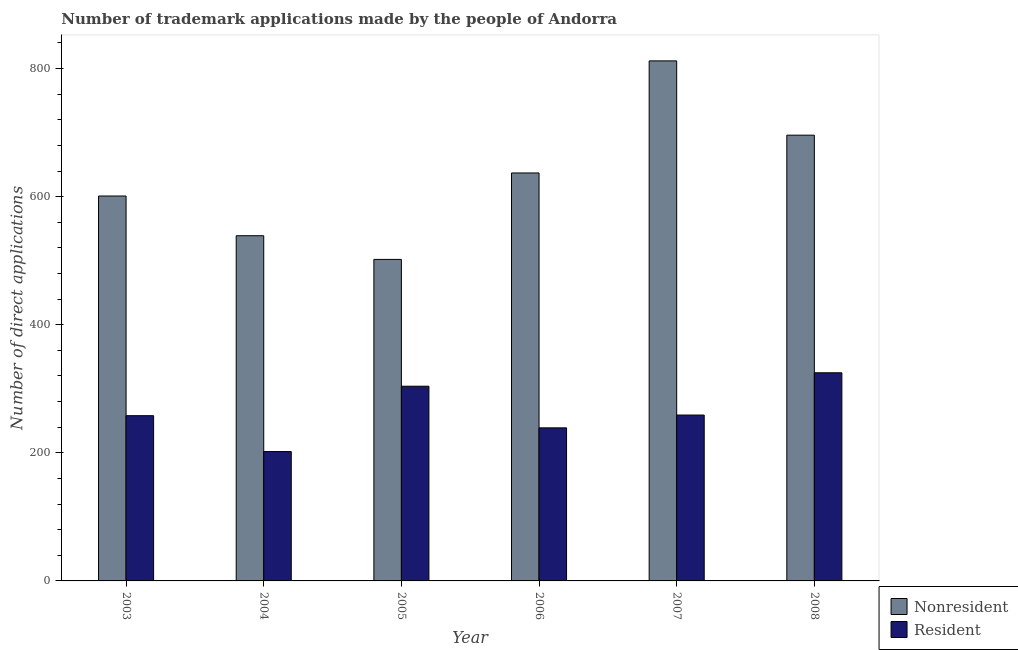How many different coloured bars are there?
Give a very brief answer. 2. Are the number of bars on each tick of the X-axis equal?
Provide a short and direct response. Yes. How many bars are there on the 6th tick from the left?
Keep it short and to the point. 2. How many bars are there on the 6th tick from the right?
Ensure brevity in your answer.  2. What is the number of trademark applications made by residents in 2004?
Provide a succinct answer. 202. Across all years, what is the maximum number of trademark applications made by residents?
Ensure brevity in your answer.  325. Across all years, what is the minimum number of trademark applications made by non residents?
Your response must be concise. 502. In which year was the number of trademark applications made by non residents minimum?
Ensure brevity in your answer.  2005. What is the total number of trademark applications made by non residents in the graph?
Ensure brevity in your answer.  3787. What is the difference between the number of trademark applications made by non residents in 2004 and that in 2007?
Give a very brief answer. -273. What is the difference between the number of trademark applications made by residents in 2005 and the number of trademark applications made by non residents in 2006?
Ensure brevity in your answer.  65. What is the average number of trademark applications made by non residents per year?
Ensure brevity in your answer.  631.17. In the year 2006, what is the difference between the number of trademark applications made by residents and number of trademark applications made by non residents?
Ensure brevity in your answer.  0. In how many years, is the number of trademark applications made by residents greater than 560?
Keep it short and to the point. 0. What is the ratio of the number of trademark applications made by non residents in 2005 to that in 2008?
Keep it short and to the point. 0.72. Is the number of trademark applications made by residents in 2003 less than that in 2006?
Offer a terse response. No. Is the difference between the number of trademark applications made by residents in 2005 and 2006 greater than the difference between the number of trademark applications made by non residents in 2005 and 2006?
Provide a succinct answer. No. What is the difference between the highest and the second highest number of trademark applications made by non residents?
Offer a terse response. 116. What is the difference between the highest and the lowest number of trademark applications made by residents?
Make the answer very short. 123. What does the 2nd bar from the left in 2003 represents?
Your answer should be very brief. Resident. What does the 1st bar from the right in 2004 represents?
Your answer should be very brief. Resident. How many bars are there?
Provide a short and direct response. 12. Are all the bars in the graph horizontal?
Your answer should be very brief. No. How many years are there in the graph?
Your answer should be very brief. 6. Does the graph contain any zero values?
Give a very brief answer. No. Where does the legend appear in the graph?
Give a very brief answer. Bottom right. How many legend labels are there?
Ensure brevity in your answer.  2. How are the legend labels stacked?
Ensure brevity in your answer.  Vertical. What is the title of the graph?
Your answer should be very brief. Number of trademark applications made by the people of Andorra. What is the label or title of the Y-axis?
Your answer should be compact. Number of direct applications. What is the Number of direct applications in Nonresident in 2003?
Provide a succinct answer. 601. What is the Number of direct applications in Resident in 2003?
Provide a short and direct response. 258. What is the Number of direct applications in Nonresident in 2004?
Ensure brevity in your answer.  539. What is the Number of direct applications in Resident in 2004?
Your answer should be compact. 202. What is the Number of direct applications in Nonresident in 2005?
Offer a very short reply. 502. What is the Number of direct applications of Resident in 2005?
Your response must be concise. 304. What is the Number of direct applications of Nonresident in 2006?
Offer a very short reply. 637. What is the Number of direct applications of Resident in 2006?
Your answer should be very brief. 239. What is the Number of direct applications in Nonresident in 2007?
Provide a succinct answer. 812. What is the Number of direct applications of Resident in 2007?
Your answer should be compact. 259. What is the Number of direct applications in Nonresident in 2008?
Offer a terse response. 696. What is the Number of direct applications in Resident in 2008?
Give a very brief answer. 325. Across all years, what is the maximum Number of direct applications in Nonresident?
Your answer should be compact. 812. Across all years, what is the maximum Number of direct applications of Resident?
Offer a very short reply. 325. Across all years, what is the minimum Number of direct applications of Nonresident?
Keep it short and to the point. 502. Across all years, what is the minimum Number of direct applications of Resident?
Give a very brief answer. 202. What is the total Number of direct applications of Nonresident in the graph?
Provide a short and direct response. 3787. What is the total Number of direct applications of Resident in the graph?
Ensure brevity in your answer.  1587. What is the difference between the Number of direct applications in Nonresident in 2003 and that in 2004?
Keep it short and to the point. 62. What is the difference between the Number of direct applications of Resident in 2003 and that in 2005?
Your answer should be compact. -46. What is the difference between the Number of direct applications of Nonresident in 2003 and that in 2006?
Provide a short and direct response. -36. What is the difference between the Number of direct applications of Resident in 2003 and that in 2006?
Your answer should be very brief. 19. What is the difference between the Number of direct applications in Nonresident in 2003 and that in 2007?
Offer a very short reply. -211. What is the difference between the Number of direct applications of Nonresident in 2003 and that in 2008?
Your response must be concise. -95. What is the difference between the Number of direct applications of Resident in 2003 and that in 2008?
Your response must be concise. -67. What is the difference between the Number of direct applications of Resident in 2004 and that in 2005?
Your answer should be compact. -102. What is the difference between the Number of direct applications of Nonresident in 2004 and that in 2006?
Your answer should be compact. -98. What is the difference between the Number of direct applications in Resident in 2004 and that in 2006?
Give a very brief answer. -37. What is the difference between the Number of direct applications in Nonresident in 2004 and that in 2007?
Offer a terse response. -273. What is the difference between the Number of direct applications in Resident in 2004 and that in 2007?
Your answer should be compact. -57. What is the difference between the Number of direct applications in Nonresident in 2004 and that in 2008?
Give a very brief answer. -157. What is the difference between the Number of direct applications of Resident in 2004 and that in 2008?
Your answer should be compact. -123. What is the difference between the Number of direct applications in Nonresident in 2005 and that in 2006?
Your answer should be very brief. -135. What is the difference between the Number of direct applications of Resident in 2005 and that in 2006?
Your response must be concise. 65. What is the difference between the Number of direct applications in Nonresident in 2005 and that in 2007?
Ensure brevity in your answer.  -310. What is the difference between the Number of direct applications in Nonresident in 2005 and that in 2008?
Offer a terse response. -194. What is the difference between the Number of direct applications in Resident in 2005 and that in 2008?
Offer a very short reply. -21. What is the difference between the Number of direct applications of Nonresident in 2006 and that in 2007?
Your answer should be compact. -175. What is the difference between the Number of direct applications in Resident in 2006 and that in 2007?
Provide a succinct answer. -20. What is the difference between the Number of direct applications in Nonresident in 2006 and that in 2008?
Keep it short and to the point. -59. What is the difference between the Number of direct applications in Resident in 2006 and that in 2008?
Your answer should be compact. -86. What is the difference between the Number of direct applications of Nonresident in 2007 and that in 2008?
Keep it short and to the point. 116. What is the difference between the Number of direct applications in Resident in 2007 and that in 2008?
Your response must be concise. -66. What is the difference between the Number of direct applications of Nonresident in 2003 and the Number of direct applications of Resident in 2004?
Ensure brevity in your answer.  399. What is the difference between the Number of direct applications in Nonresident in 2003 and the Number of direct applications in Resident in 2005?
Offer a very short reply. 297. What is the difference between the Number of direct applications of Nonresident in 2003 and the Number of direct applications of Resident in 2006?
Ensure brevity in your answer.  362. What is the difference between the Number of direct applications in Nonresident in 2003 and the Number of direct applications in Resident in 2007?
Your answer should be compact. 342. What is the difference between the Number of direct applications in Nonresident in 2003 and the Number of direct applications in Resident in 2008?
Offer a terse response. 276. What is the difference between the Number of direct applications of Nonresident in 2004 and the Number of direct applications of Resident in 2005?
Your response must be concise. 235. What is the difference between the Number of direct applications of Nonresident in 2004 and the Number of direct applications of Resident in 2006?
Ensure brevity in your answer.  300. What is the difference between the Number of direct applications of Nonresident in 2004 and the Number of direct applications of Resident in 2007?
Give a very brief answer. 280. What is the difference between the Number of direct applications in Nonresident in 2004 and the Number of direct applications in Resident in 2008?
Offer a very short reply. 214. What is the difference between the Number of direct applications in Nonresident in 2005 and the Number of direct applications in Resident in 2006?
Offer a very short reply. 263. What is the difference between the Number of direct applications of Nonresident in 2005 and the Number of direct applications of Resident in 2007?
Ensure brevity in your answer.  243. What is the difference between the Number of direct applications in Nonresident in 2005 and the Number of direct applications in Resident in 2008?
Offer a terse response. 177. What is the difference between the Number of direct applications of Nonresident in 2006 and the Number of direct applications of Resident in 2007?
Offer a very short reply. 378. What is the difference between the Number of direct applications in Nonresident in 2006 and the Number of direct applications in Resident in 2008?
Your answer should be very brief. 312. What is the difference between the Number of direct applications of Nonresident in 2007 and the Number of direct applications of Resident in 2008?
Give a very brief answer. 487. What is the average Number of direct applications in Nonresident per year?
Your answer should be very brief. 631.17. What is the average Number of direct applications of Resident per year?
Offer a very short reply. 264.5. In the year 2003, what is the difference between the Number of direct applications in Nonresident and Number of direct applications in Resident?
Offer a terse response. 343. In the year 2004, what is the difference between the Number of direct applications of Nonresident and Number of direct applications of Resident?
Your answer should be compact. 337. In the year 2005, what is the difference between the Number of direct applications of Nonresident and Number of direct applications of Resident?
Keep it short and to the point. 198. In the year 2006, what is the difference between the Number of direct applications of Nonresident and Number of direct applications of Resident?
Give a very brief answer. 398. In the year 2007, what is the difference between the Number of direct applications in Nonresident and Number of direct applications in Resident?
Your response must be concise. 553. In the year 2008, what is the difference between the Number of direct applications in Nonresident and Number of direct applications in Resident?
Make the answer very short. 371. What is the ratio of the Number of direct applications in Nonresident in 2003 to that in 2004?
Give a very brief answer. 1.11. What is the ratio of the Number of direct applications of Resident in 2003 to that in 2004?
Make the answer very short. 1.28. What is the ratio of the Number of direct applications of Nonresident in 2003 to that in 2005?
Provide a succinct answer. 1.2. What is the ratio of the Number of direct applications in Resident in 2003 to that in 2005?
Offer a terse response. 0.85. What is the ratio of the Number of direct applications in Nonresident in 2003 to that in 2006?
Your answer should be compact. 0.94. What is the ratio of the Number of direct applications in Resident in 2003 to that in 2006?
Your answer should be very brief. 1.08. What is the ratio of the Number of direct applications in Nonresident in 2003 to that in 2007?
Provide a short and direct response. 0.74. What is the ratio of the Number of direct applications in Nonresident in 2003 to that in 2008?
Provide a short and direct response. 0.86. What is the ratio of the Number of direct applications of Resident in 2003 to that in 2008?
Your answer should be compact. 0.79. What is the ratio of the Number of direct applications in Nonresident in 2004 to that in 2005?
Your answer should be very brief. 1.07. What is the ratio of the Number of direct applications of Resident in 2004 to that in 2005?
Provide a short and direct response. 0.66. What is the ratio of the Number of direct applications in Nonresident in 2004 to that in 2006?
Ensure brevity in your answer.  0.85. What is the ratio of the Number of direct applications of Resident in 2004 to that in 2006?
Your answer should be very brief. 0.85. What is the ratio of the Number of direct applications of Nonresident in 2004 to that in 2007?
Offer a terse response. 0.66. What is the ratio of the Number of direct applications of Resident in 2004 to that in 2007?
Your answer should be compact. 0.78. What is the ratio of the Number of direct applications in Nonresident in 2004 to that in 2008?
Give a very brief answer. 0.77. What is the ratio of the Number of direct applications of Resident in 2004 to that in 2008?
Provide a succinct answer. 0.62. What is the ratio of the Number of direct applications of Nonresident in 2005 to that in 2006?
Ensure brevity in your answer.  0.79. What is the ratio of the Number of direct applications in Resident in 2005 to that in 2006?
Keep it short and to the point. 1.27. What is the ratio of the Number of direct applications in Nonresident in 2005 to that in 2007?
Offer a very short reply. 0.62. What is the ratio of the Number of direct applications of Resident in 2005 to that in 2007?
Offer a terse response. 1.17. What is the ratio of the Number of direct applications of Nonresident in 2005 to that in 2008?
Give a very brief answer. 0.72. What is the ratio of the Number of direct applications of Resident in 2005 to that in 2008?
Keep it short and to the point. 0.94. What is the ratio of the Number of direct applications in Nonresident in 2006 to that in 2007?
Your answer should be very brief. 0.78. What is the ratio of the Number of direct applications in Resident in 2006 to that in 2007?
Your answer should be very brief. 0.92. What is the ratio of the Number of direct applications of Nonresident in 2006 to that in 2008?
Your answer should be very brief. 0.92. What is the ratio of the Number of direct applications of Resident in 2006 to that in 2008?
Your response must be concise. 0.74. What is the ratio of the Number of direct applications in Resident in 2007 to that in 2008?
Your response must be concise. 0.8. What is the difference between the highest and the second highest Number of direct applications in Nonresident?
Give a very brief answer. 116. What is the difference between the highest and the lowest Number of direct applications in Nonresident?
Your response must be concise. 310. What is the difference between the highest and the lowest Number of direct applications in Resident?
Make the answer very short. 123. 